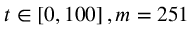<formula> <loc_0><loc_0><loc_500><loc_500>t \in \left [ 0 , 1 0 0 \right ] , m = 2 5 1</formula> 